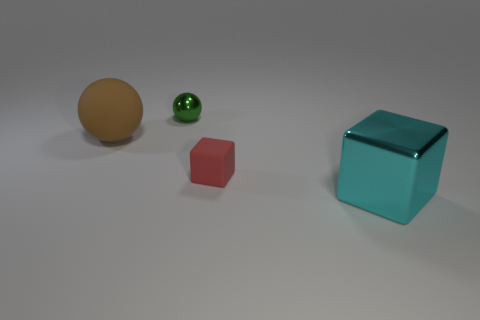Subtract all brown balls. How many balls are left? 1 Add 1 large brown things. How many objects exist? 5 Add 2 red cubes. How many red cubes exist? 3 Subtract 0 green blocks. How many objects are left? 4 Subtract all red matte objects. Subtract all small rubber blocks. How many objects are left? 2 Add 3 big brown objects. How many big brown objects are left? 4 